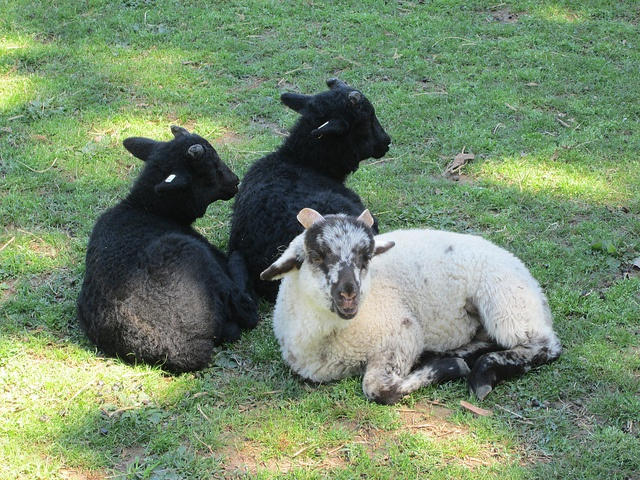Describe the objects in this image and their specific colors. I can see sheep in olive, lightgray, darkgray, gray, and black tones, sheep in olive, black, and gray tones, and sheep in olive, black, navy, darkblue, and purple tones in this image. 